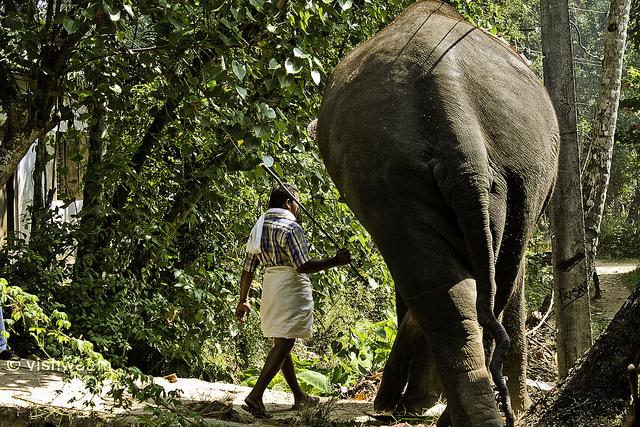Is this a zoo setting?
Be succinct. No. Is there a writing on a tree?
Give a very brief answer. Yes. Are these elephants?
Write a very short answer. Yes. Is this elephant in a circus?
Write a very short answer. No. Is this a zoo elephant?
Concise answer only. No. What animal is this?
Write a very short answer. Elephant. 